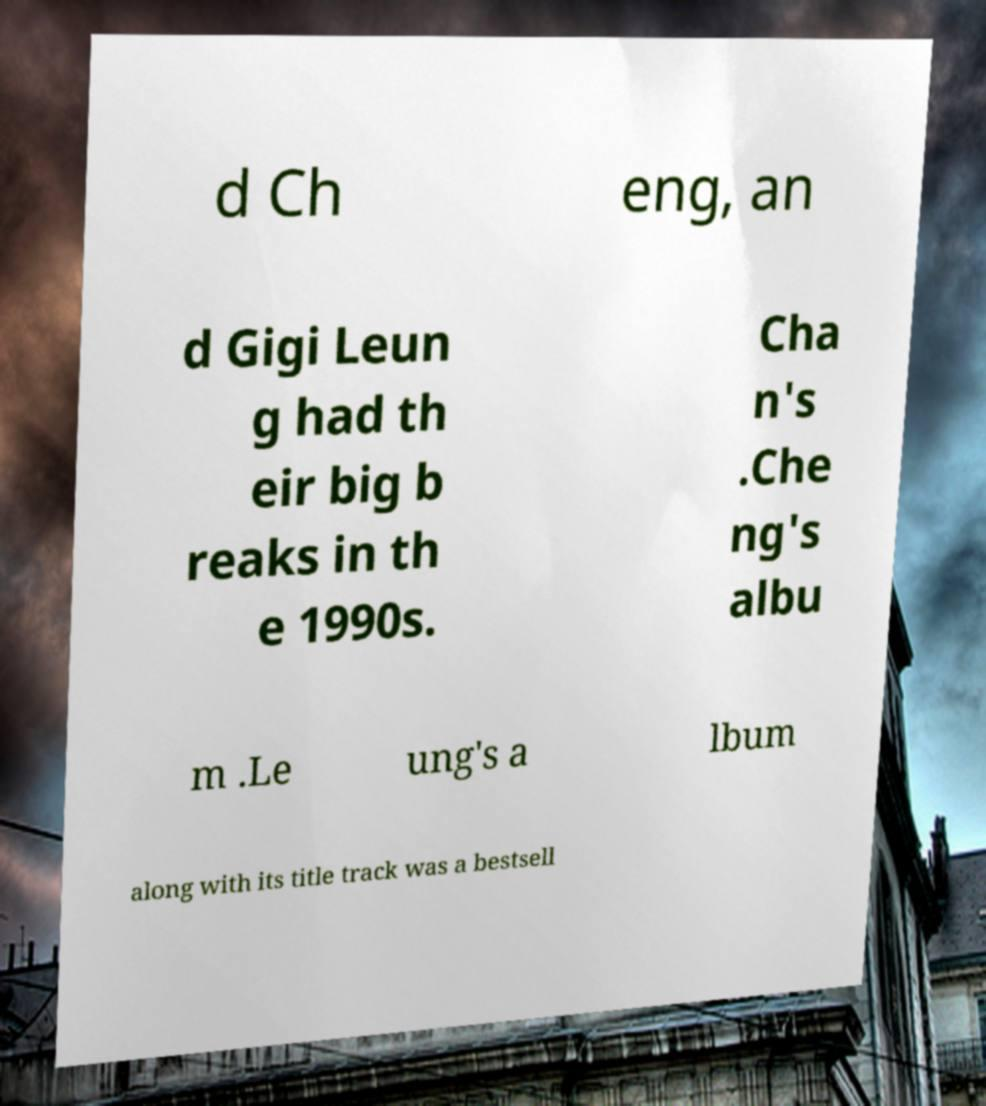Could you assist in decoding the text presented in this image and type it out clearly? d Ch eng, an d Gigi Leun g had th eir big b reaks in th e 1990s. Cha n's .Che ng's albu m .Le ung's a lbum along with its title track was a bestsell 